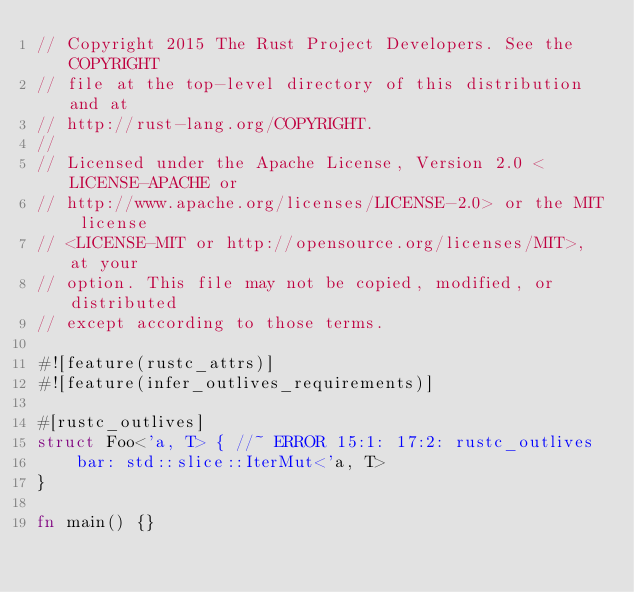<code> <loc_0><loc_0><loc_500><loc_500><_Rust_>// Copyright 2015 The Rust Project Developers. See the COPYRIGHT
// file at the top-level directory of this distribution and at
// http://rust-lang.org/COPYRIGHT.
//
// Licensed under the Apache License, Version 2.0 <LICENSE-APACHE or
// http://www.apache.org/licenses/LICENSE-2.0> or the MIT license
// <LICENSE-MIT or http://opensource.org/licenses/MIT>, at your
// option. This file may not be copied, modified, or distributed
// except according to those terms.

#![feature(rustc_attrs)]
#![feature(infer_outlives_requirements)]

#[rustc_outlives]
struct Foo<'a, T> { //~ ERROR 15:1: 17:2: rustc_outlives
    bar: std::slice::IterMut<'a, T>
}

fn main() {}

</code> 